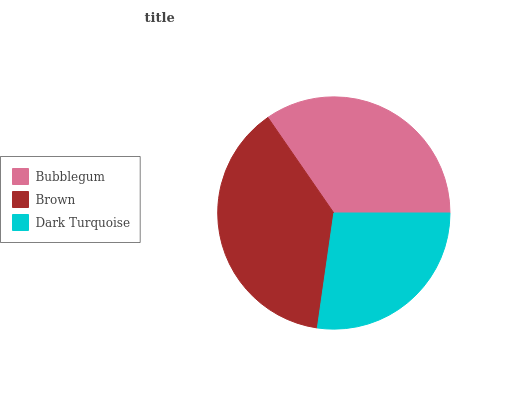Is Dark Turquoise the minimum?
Answer yes or no. Yes. Is Brown the maximum?
Answer yes or no. Yes. Is Brown the minimum?
Answer yes or no. No. Is Dark Turquoise the maximum?
Answer yes or no. No. Is Brown greater than Dark Turquoise?
Answer yes or no. Yes. Is Dark Turquoise less than Brown?
Answer yes or no. Yes. Is Dark Turquoise greater than Brown?
Answer yes or no. No. Is Brown less than Dark Turquoise?
Answer yes or no. No. Is Bubblegum the high median?
Answer yes or no. Yes. Is Bubblegum the low median?
Answer yes or no. Yes. Is Brown the high median?
Answer yes or no. No. Is Dark Turquoise the low median?
Answer yes or no. No. 